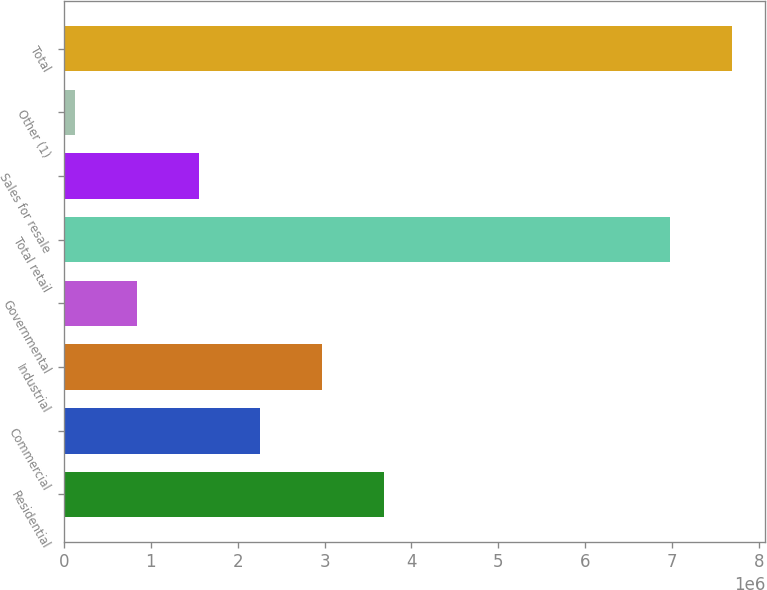Convert chart to OTSL. <chart><loc_0><loc_0><loc_500><loc_500><bar_chart><fcel>Residential<fcel>Commercial<fcel>Industrial<fcel>Governmental<fcel>Total retail<fcel>Sales for resale<fcel>Other (1)<fcel>Total<nl><fcel>3.68608e+06<fcel>2.26258e+06<fcel>2.97433e+06<fcel>839083<fcel>6.97681e+06<fcel>1.55083e+06<fcel>127334<fcel>7.68856e+06<nl></chart> 